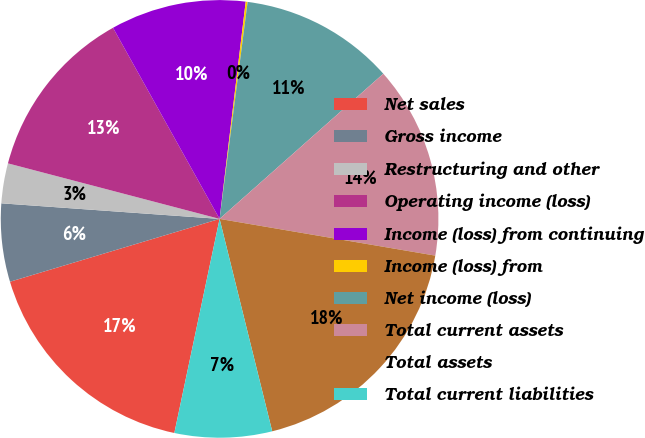Convert chart. <chart><loc_0><loc_0><loc_500><loc_500><pie_chart><fcel>Net sales<fcel>Gross income<fcel>Restructuring and other<fcel>Operating income (loss)<fcel>Income (loss) from continuing<fcel>Income (loss) from<fcel>Net income (loss)<fcel>Total current assets<fcel>Total assets<fcel>Total current liabilities<nl><fcel>17.05%<fcel>5.77%<fcel>2.95%<fcel>12.82%<fcel>10.0%<fcel>0.14%<fcel>11.41%<fcel>14.23%<fcel>18.45%<fcel>7.18%<nl></chart> 